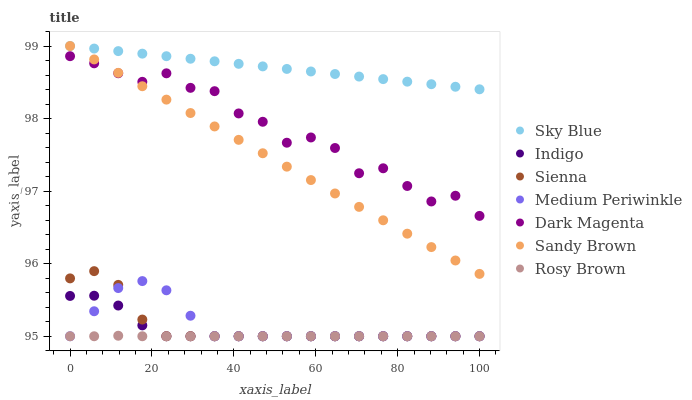Does Rosy Brown have the minimum area under the curve?
Answer yes or no. Yes. Does Sky Blue have the maximum area under the curve?
Answer yes or no. Yes. Does Dark Magenta have the minimum area under the curve?
Answer yes or no. No. Does Dark Magenta have the maximum area under the curve?
Answer yes or no. No. Is Sky Blue the smoothest?
Answer yes or no. Yes. Is Dark Magenta the roughest?
Answer yes or no. Yes. Is Rosy Brown the smoothest?
Answer yes or no. No. Is Rosy Brown the roughest?
Answer yes or no. No. Does Indigo have the lowest value?
Answer yes or no. Yes. Does Dark Magenta have the lowest value?
Answer yes or no. No. Does Sandy Brown have the highest value?
Answer yes or no. Yes. Does Dark Magenta have the highest value?
Answer yes or no. No. Is Rosy Brown less than Sky Blue?
Answer yes or no. Yes. Is Sandy Brown greater than Indigo?
Answer yes or no. Yes. Does Medium Periwinkle intersect Sienna?
Answer yes or no. Yes. Is Medium Periwinkle less than Sienna?
Answer yes or no. No. Is Medium Periwinkle greater than Sienna?
Answer yes or no. No. Does Rosy Brown intersect Sky Blue?
Answer yes or no. No. 